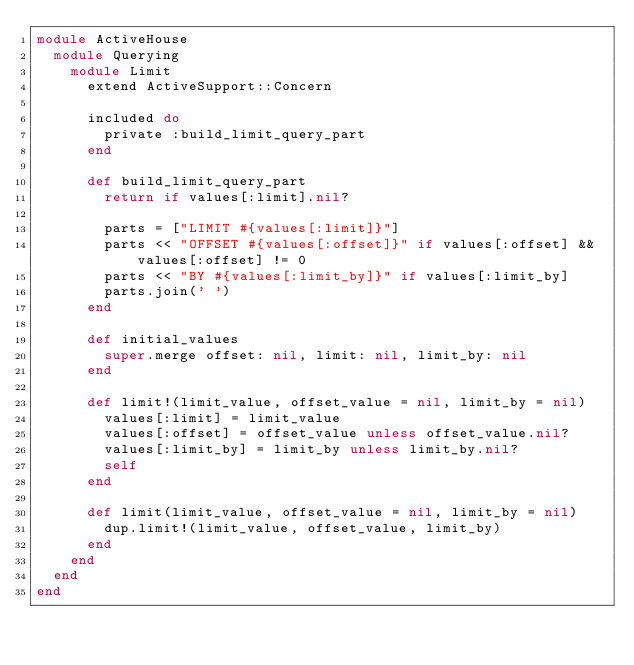<code> <loc_0><loc_0><loc_500><loc_500><_Ruby_>module ActiveHouse
  module Querying
    module Limit
      extend ActiveSupport::Concern

      included do
        private :build_limit_query_part
      end

      def build_limit_query_part
        return if values[:limit].nil?

        parts = ["LIMIT #{values[:limit]}"]
        parts << "OFFSET #{values[:offset]}" if values[:offset] && values[:offset] != 0
        parts << "BY #{values[:limit_by]}" if values[:limit_by]
        parts.join(' ')
      end

      def initial_values
        super.merge offset: nil, limit: nil, limit_by: nil
      end

      def limit!(limit_value, offset_value = nil, limit_by = nil)
        values[:limit] = limit_value
        values[:offset] = offset_value unless offset_value.nil?
        values[:limit_by] = limit_by unless limit_by.nil?
        self
      end

      def limit(limit_value, offset_value = nil, limit_by = nil)
        dup.limit!(limit_value, offset_value, limit_by)
      end
    end
  end
end
</code> 